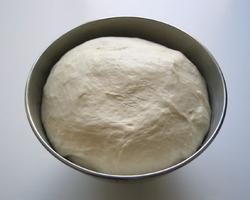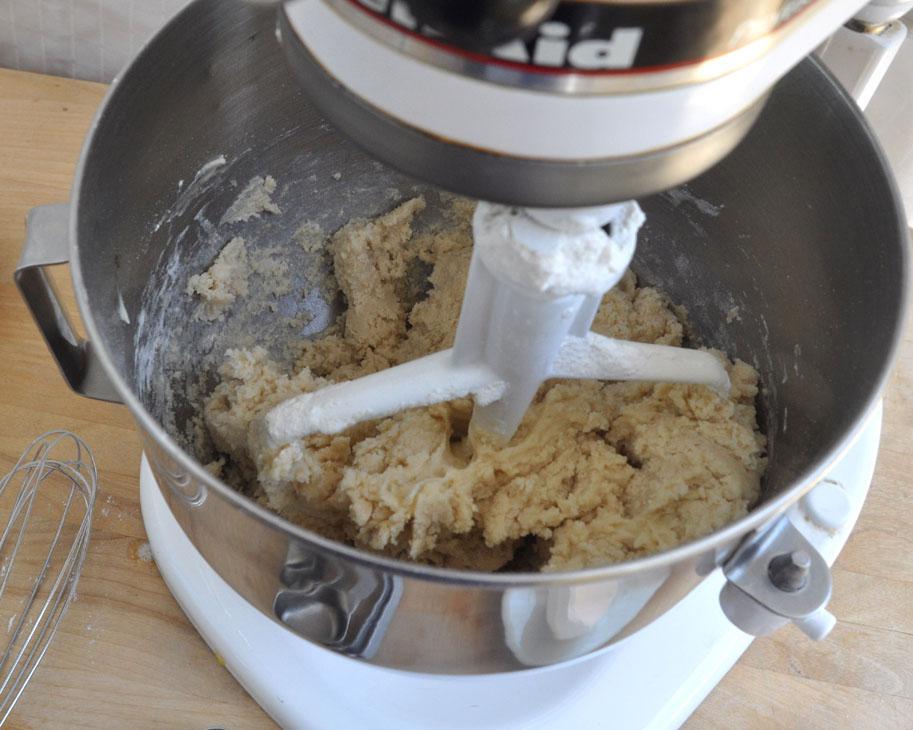The first image is the image on the left, the second image is the image on the right. Evaluate the accuracy of this statement regarding the images: "There is a white bowl with dough and a silver utensil is stuck in the dough". Is it true? Answer yes or no. No. 